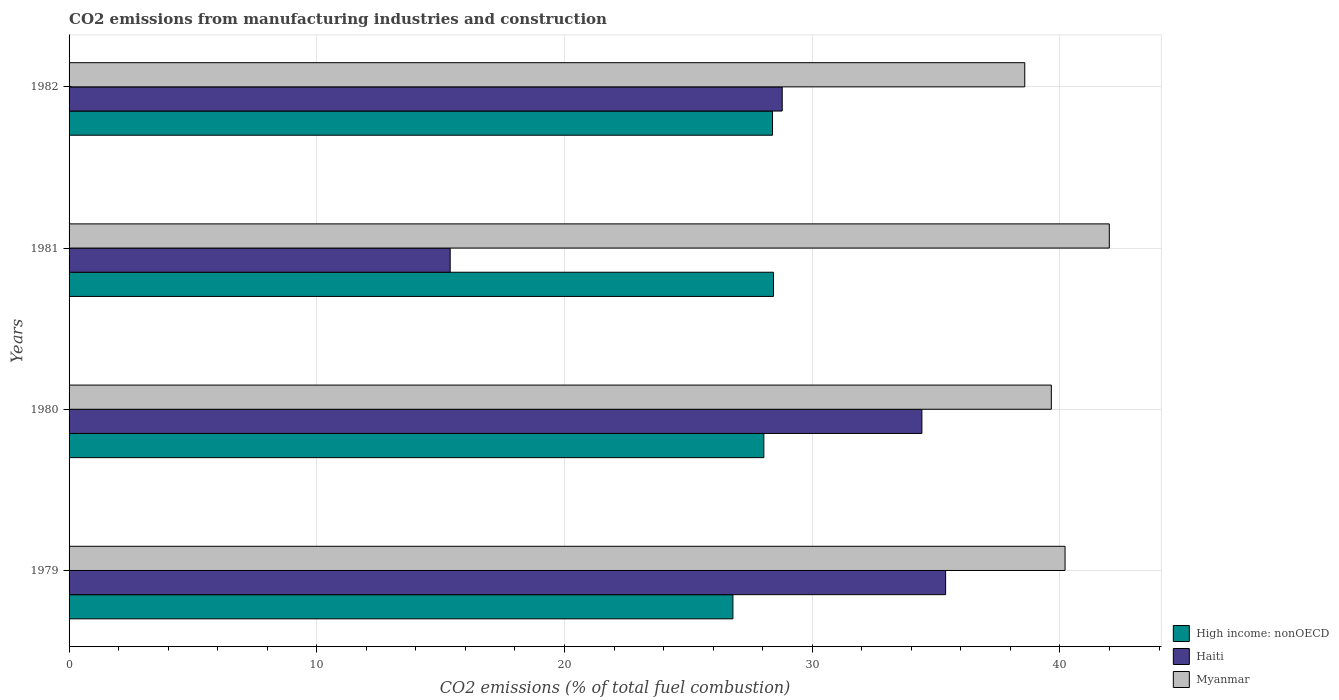How many groups of bars are there?
Provide a succinct answer. 4. What is the label of the 4th group of bars from the top?
Keep it short and to the point. 1979. In how many cases, is the number of bars for a given year not equal to the number of legend labels?
Keep it short and to the point. 0. What is the amount of CO2 emitted in High income: nonOECD in 1979?
Provide a succinct answer. 26.8. Across all years, what is the maximum amount of CO2 emitted in Myanmar?
Offer a terse response. 41.99. Across all years, what is the minimum amount of CO2 emitted in Haiti?
Provide a succinct answer. 15.38. In which year was the amount of CO2 emitted in Myanmar maximum?
Offer a very short reply. 1981. In which year was the amount of CO2 emitted in High income: nonOECD minimum?
Your answer should be compact. 1979. What is the total amount of CO2 emitted in Myanmar in the graph?
Provide a short and direct response. 160.43. What is the difference between the amount of CO2 emitted in Haiti in 1980 and that in 1981?
Ensure brevity in your answer.  19.04. What is the difference between the amount of CO2 emitted in High income: nonOECD in 1981 and the amount of CO2 emitted in Haiti in 1980?
Offer a terse response. -5.99. What is the average amount of CO2 emitted in Myanmar per year?
Your response must be concise. 40.11. In the year 1980, what is the difference between the amount of CO2 emitted in Myanmar and amount of CO2 emitted in High income: nonOECD?
Your response must be concise. 11.61. In how many years, is the amount of CO2 emitted in Haiti greater than 42 %?
Make the answer very short. 0. What is the ratio of the amount of CO2 emitted in High income: nonOECD in 1979 to that in 1980?
Your answer should be very brief. 0.96. Is the amount of CO2 emitted in Myanmar in 1979 less than that in 1982?
Provide a short and direct response. No. What is the difference between the highest and the second highest amount of CO2 emitted in High income: nonOECD?
Give a very brief answer. 0.04. What is the difference between the highest and the lowest amount of CO2 emitted in High income: nonOECD?
Offer a very short reply. 1.64. What does the 2nd bar from the top in 1982 represents?
Your answer should be very brief. Haiti. What does the 2nd bar from the bottom in 1979 represents?
Your answer should be very brief. Haiti. Is it the case that in every year, the sum of the amount of CO2 emitted in High income: nonOECD and amount of CO2 emitted in Myanmar is greater than the amount of CO2 emitted in Haiti?
Your answer should be compact. Yes. How many bars are there?
Make the answer very short. 12. How many years are there in the graph?
Offer a very short reply. 4. What is the difference between two consecutive major ticks on the X-axis?
Keep it short and to the point. 10. Are the values on the major ticks of X-axis written in scientific E-notation?
Keep it short and to the point. No. Where does the legend appear in the graph?
Your answer should be compact. Bottom right. How many legend labels are there?
Ensure brevity in your answer.  3. How are the legend labels stacked?
Offer a terse response. Vertical. What is the title of the graph?
Your answer should be very brief. CO2 emissions from manufacturing industries and construction. What is the label or title of the X-axis?
Offer a very short reply. CO2 emissions (% of total fuel combustion). What is the label or title of the Y-axis?
Offer a very short reply. Years. What is the CO2 emissions (% of total fuel combustion) in High income: nonOECD in 1979?
Offer a terse response. 26.8. What is the CO2 emissions (% of total fuel combustion) of Haiti in 1979?
Your response must be concise. 35.38. What is the CO2 emissions (% of total fuel combustion) in Myanmar in 1979?
Your answer should be very brief. 40.21. What is the CO2 emissions (% of total fuel combustion) of High income: nonOECD in 1980?
Provide a short and direct response. 28.05. What is the CO2 emissions (% of total fuel combustion) in Haiti in 1980?
Keep it short and to the point. 34.43. What is the CO2 emissions (% of total fuel combustion) of Myanmar in 1980?
Provide a succinct answer. 39.65. What is the CO2 emissions (% of total fuel combustion) of High income: nonOECD in 1981?
Your answer should be very brief. 28.44. What is the CO2 emissions (% of total fuel combustion) in Haiti in 1981?
Your answer should be compact. 15.38. What is the CO2 emissions (% of total fuel combustion) of Myanmar in 1981?
Offer a very short reply. 41.99. What is the CO2 emissions (% of total fuel combustion) in High income: nonOECD in 1982?
Your answer should be very brief. 28.4. What is the CO2 emissions (% of total fuel combustion) in Haiti in 1982?
Provide a short and direct response. 28.79. What is the CO2 emissions (% of total fuel combustion) of Myanmar in 1982?
Ensure brevity in your answer.  38.58. Across all years, what is the maximum CO2 emissions (% of total fuel combustion) of High income: nonOECD?
Offer a terse response. 28.44. Across all years, what is the maximum CO2 emissions (% of total fuel combustion) in Haiti?
Provide a short and direct response. 35.38. Across all years, what is the maximum CO2 emissions (% of total fuel combustion) in Myanmar?
Offer a very short reply. 41.99. Across all years, what is the minimum CO2 emissions (% of total fuel combustion) of High income: nonOECD?
Your answer should be very brief. 26.8. Across all years, what is the minimum CO2 emissions (% of total fuel combustion) in Haiti?
Your answer should be very brief. 15.38. Across all years, what is the minimum CO2 emissions (% of total fuel combustion) of Myanmar?
Provide a short and direct response. 38.58. What is the total CO2 emissions (% of total fuel combustion) of High income: nonOECD in the graph?
Keep it short and to the point. 111.68. What is the total CO2 emissions (% of total fuel combustion) in Haiti in the graph?
Your answer should be very brief. 113.98. What is the total CO2 emissions (% of total fuel combustion) of Myanmar in the graph?
Your answer should be very brief. 160.43. What is the difference between the CO2 emissions (% of total fuel combustion) of High income: nonOECD in 1979 and that in 1980?
Your response must be concise. -1.25. What is the difference between the CO2 emissions (% of total fuel combustion) of Haiti in 1979 and that in 1980?
Offer a terse response. 0.96. What is the difference between the CO2 emissions (% of total fuel combustion) of Myanmar in 1979 and that in 1980?
Your answer should be compact. 0.55. What is the difference between the CO2 emissions (% of total fuel combustion) in High income: nonOECD in 1979 and that in 1981?
Keep it short and to the point. -1.64. What is the difference between the CO2 emissions (% of total fuel combustion) in Myanmar in 1979 and that in 1981?
Your answer should be very brief. -1.79. What is the difference between the CO2 emissions (% of total fuel combustion) of High income: nonOECD in 1979 and that in 1982?
Offer a very short reply. -1.6. What is the difference between the CO2 emissions (% of total fuel combustion) in Haiti in 1979 and that in 1982?
Provide a short and direct response. 6.6. What is the difference between the CO2 emissions (% of total fuel combustion) in Myanmar in 1979 and that in 1982?
Offer a terse response. 1.63. What is the difference between the CO2 emissions (% of total fuel combustion) of High income: nonOECD in 1980 and that in 1981?
Your response must be concise. -0.39. What is the difference between the CO2 emissions (% of total fuel combustion) of Haiti in 1980 and that in 1981?
Offer a very short reply. 19.04. What is the difference between the CO2 emissions (% of total fuel combustion) of Myanmar in 1980 and that in 1981?
Make the answer very short. -2.34. What is the difference between the CO2 emissions (% of total fuel combustion) in High income: nonOECD in 1980 and that in 1982?
Offer a very short reply. -0.35. What is the difference between the CO2 emissions (% of total fuel combustion) of Haiti in 1980 and that in 1982?
Your answer should be very brief. 5.64. What is the difference between the CO2 emissions (% of total fuel combustion) in Myanmar in 1980 and that in 1982?
Provide a short and direct response. 1.07. What is the difference between the CO2 emissions (% of total fuel combustion) in High income: nonOECD in 1981 and that in 1982?
Provide a succinct answer. 0.04. What is the difference between the CO2 emissions (% of total fuel combustion) of Haiti in 1981 and that in 1982?
Provide a short and direct response. -13.4. What is the difference between the CO2 emissions (% of total fuel combustion) of Myanmar in 1981 and that in 1982?
Keep it short and to the point. 3.41. What is the difference between the CO2 emissions (% of total fuel combustion) of High income: nonOECD in 1979 and the CO2 emissions (% of total fuel combustion) of Haiti in 1980?
Ensure brevity in your answer.  -7.63. What is the difference between the CO2 emissions (% of total fuel combustion) of High income: nonOECD in 1979 and the CO2 emissions (% of total fuel combustion) of Myanmar in 1980?
Keep it short and to the point. -12.85. What is the difference between the CO2 emissions (% of total fuel combustion) in Haiti in 1979 and the CO2 emissions (% of total fuel combustion) in Myanmar in 1980?
Give a very brief answer. -4.27. What is the difference between the CO2 emissions (% of total fuel combustion) of High income: nonOECD in 1979 and the CO2 emissions (% of total fuel combustion) of Haiti in 1981?
Provide a short and direct response. 11.41. What is the difference between the CO2 emissions (% of total fuel combustion) in High income: nonOECD in 1979 and the CO2 emissions (% of total fuel combustion) in Myanmar in 1981?
Offer a terse response. -15.19. What is the difference between the CO2 emissions (% of total fuel combustion) in Haiti in 1979 and the CO2 emissions (% of total fuel combustion) in Myanmar in 1981?
Keep it short and to the point. -6.61. What is the difference between the CO2 emissions (% of total fuel combustion) in High income: nonOECD in 1979 and the CO2 emissions (% of total fuel combustion) in Haiti in 1982?
Offer a terse response. -1.99. What is the difference between the CO2 emissions (% of total fuel combustion) of High income: nonOECD in 1979 and the CO2 emissions (% of total fuel combustion) of Myanmar in 1982?
Your answer should be compact. -11.78. What is the difference between the CO2 emissions (% of total fuel combustion) in Haiti in 1979 and the CO2 emissions (% of total fuel combustion) in Myanmar in 1982?
Offer a terse response. -3.19. What is the difference between the CO2 emissions (% of total fuel combustion) of High income: nonOECD in 1980 and the CO2 emissions (% of total fuel combustion) of Haiti in 1981?
Offer a terse response. 12.66. What is the difference between the CO2 emissions (% of total fuel combustion) of High income: nonOECD in 1980 and the CO2 emissions (% of total fuel combustion) of Myanmar in 1981?
Give a very brief answer. -13.95. What is the difference between the CO2 emissions (% of total fuel combustion) of Haiti in 1980 and the CO2 emissions (% of total fuel combustion) of Myanmar in 1981?
Give a very brief answer. -7.57. What is the difference between the CO2 emissions (% of total fuel combustion) in High income: nonOECD in 1980 and the CO2 emissions (% of total fuel combustion) in Haiti in 1982?
Provide a succinct answer. -0.74. What is the difference between the CO2 emissions (% of total fuel combustion) of High income: nonOECD in 1980 and the CO2 emissions (% of total fuel combustion) of Myanmar in 1982?
Your response must be concise. -10.53. What is the difference between the CO2 emissions (% of total fuel combustion) of Haiti in 1980 and the CO2 emissions (% of total fuel combustion) of Myanmar in 1982?
Offer a terse response. -4.15. What is the difference between the CO2 emissions (% of total fuel combustion) in High income: nonOECD in 1981 and the CO2 emissions (% of total fuel combustion) in Haiti in 1982?
Your answer should be compact. -0.35. What is the difference between the CO2 emissions (% of total fuel combustion) in High income: nonOECD in 1981 and the CO2 emissions (% of total fuel combustion) in Myanmar in 1982?
Provide a succinct answer. -10.14. What is the difference between the CO2 emissions (% of total fuel combustion) of Haiti in 1981 and the CO2 emissions (% of total fuel combustion) of Myanmar in 1982?
Your answer should be very brief. -23.2. What is the average CO2 emissions (% of total fuel combustion) of High income: nonOECD per year?
Provide a short and direct response. 27.92. What is the average CO2 emissions (% of total fuel combustion) of Haiti per year?
Provide a succinct answer. 28.5. What is the average CO2 emissions (% of total fuel combustion) in Myanmar per year?
Provide a short and direct response. 40.11. In the year 1979, what is the difference between the CO2 emissions (% of total fuel combustion) in High income: nonOECD and CO2 emissions (% of total fuel combustion) in Haiti?
Your response must be concise. -8.59. In the year 1979, what is the difference between the CO2 emissions (% of total fuel combustion) of High income: nonOECD and CO2 emissions (% of total fuel combustion) of Myanmar?
Make the answer very short. -13.41. In the year 1979, what is the difference between the CO2 emissions (% of total fuel combustion) in Haiti and CO2 emissions (% of total fuel combustion) in Myanmar?
Your answer should be very brief. -4.82. In the year 1980, what is the difference between the CO2 emissions (% of total fuel combustion) of High income: nonOECD and CO2 emissions (% of total fuel combustion) of Haiti?
Your answer should be very brief. -6.38. In the year 1980, what is the difference between the CO2 emissions (% of total fuel combustion) of High income: nonOECD and CO2 emissions (% of total fuel combustion) of Myanmar?
Provide a succinct answer. -11.61. In the year 1980, what is the difference between the CO2 emissions (% of total fuel combustion) of Haiti and CO2 emissions (% of total fuel combustion) of Myanmar?
Offer a terse response. -5.23. In the year 1981, what is the difference between the CO2 emissions (% of total fuel combustion) in High income: nonOECD and CO2 emissions (% of total fuel combustion) in Haiti?
Your response must be concise. 13.05. In the year 1981, what is the difference between the CO2 emissions (% of total fuel combustion) of High income: nonOECD and CO2 emissions (% of total fuel combustion) of Myanmar?
Offer a very short reply. -13.56. In the year 1981, what is the difference between the CO2 emissions (% of total fuel combustion) of Haiti and CO2 emissions (% of total fuel combustion) of Myanmar?
Offer a terse response. -26.61. In the year 1982, what is the difference between the CO2 emissions (% of total fuel combustion) in High income: nonOECD and CO2 emissions (% of total fuel combustion) in Haiti?
Your answer should be very brief. -0.39. In the year 1982, what is the difference between the CO2 emissions (% of total fuel combustion) of High income: nonOECD and CO2 emissions (% of total fuel combustion) of Myanmar?
Your answer should be very brief. -10.18. In the year 1982, what is the difference between the CO2 emissions (% of total fuel combustion) of Haiti and CO2 emissions (% of total fuel combustion) of Myanmar?
Offer a very short reply. -9.79. What is the ratio of the CO2 emissions (% of total fuel combustion) of High income: nonOECD in 1979 to that in 1980?
Give a very brief answer. 0.96. What is the ratio of the CO2 emissions (% of total fuel combustion) in Haiti in 1979 to that in 1980?
Give a very brief answer. 1.03. What is the ratio of the CO2 emissions (% of total fuel combustion) of Myanmar in 1979 to that in 1980?
Your answer should be very brief. 1.01. What is the ratio of the CO2 emissions (% of total fuel combustion) of High income: nonOECD in 1979 to that in 1981?
Provide a short and direct response. 0.94. What is the ratio of the CO2 emissions (% of total fuel combustion) in Myanmar in 1979 to that in 1981?
Keep it short and to the point. 0.96. What is the ratio of the CO2 emissions (% of total fuel combustion) in High income: nonOECD in 1979 to that in 1982?
Your answer should be very brief. 0.94. What is the ratio of the CO2 emissions (% of total fuel combustion) in Haiti in 1979 to that in 1982?
Ensure brevity in your answer.  1.23. What is the ratio of the CO2 emissions (% of total fuel combustion) in Myanmar in 1979 to that in 1982?
Your response must be concise. 1.04. What is the ratio of the CO2 emissions (% of total fuel combustion) of High income: nonOECD in 1980 to that in 1981?
Offer a very short reply. 0.99. What is the ratio of the CO2 emissions (% of total fuel combustion) in Haiti in 1980 to that in 1981?
Your answer should be very brief. 2.24. What is the ratio of the CO2 emissions (% of total fuel combustion) of Myanmar in 1980 to that in 1981?
Your answer should be compact. 0.94. What is the ratio of the CO2 emissions (% of total fuel combustion) in Haiti in 1980 to that in 1982?
Provide a succinct answer. 1.2. What is the ratio of the CO2 emissions (% of total fuel combustion) of Myanmar in 1980 to that in 1982?
Your answer should be very brief. 1.03. What is the ratio of the CO2 emissions (% of total fuel combustion) in Haiti in 1981 to that in 1982?
Your response must be concise. 0.53. What is the ratio of the CO2 emissions (% of total fuel combustion) in Myanmar in 1981 to that in 1982?
Make the answer very short. 1.09. What is the difference between the highest and the second highest CO2 emissions (% of total fuel combustion) of High income: nonOECD?
Give a very brief answer. 0.04. What is the difference between the highest and the second highest CO2 emissions (% of total fuel combustion) of Haiti?
Give a very brief answer. 0.96. What is the difference between the highest and the second highest CO2 emissions (% of total fuel combustion) in Myanmar?
Offer a terse response. 1.79. What is the difference between the highest and the lowest CO2 emissions (% of total fuel combustion) of High income: nonOECD?
Give a very brief answer. 1.64. What is the difference between the highest and the lowest CO2 emissions (% of total fuel combustion) of Haiti?
Offer a terse response. 20. What is the difference between the highest and the lowest CO2 emissions (% of total fuel combustion) in Myanmar?
Your answer should be very brief. 3.41. 